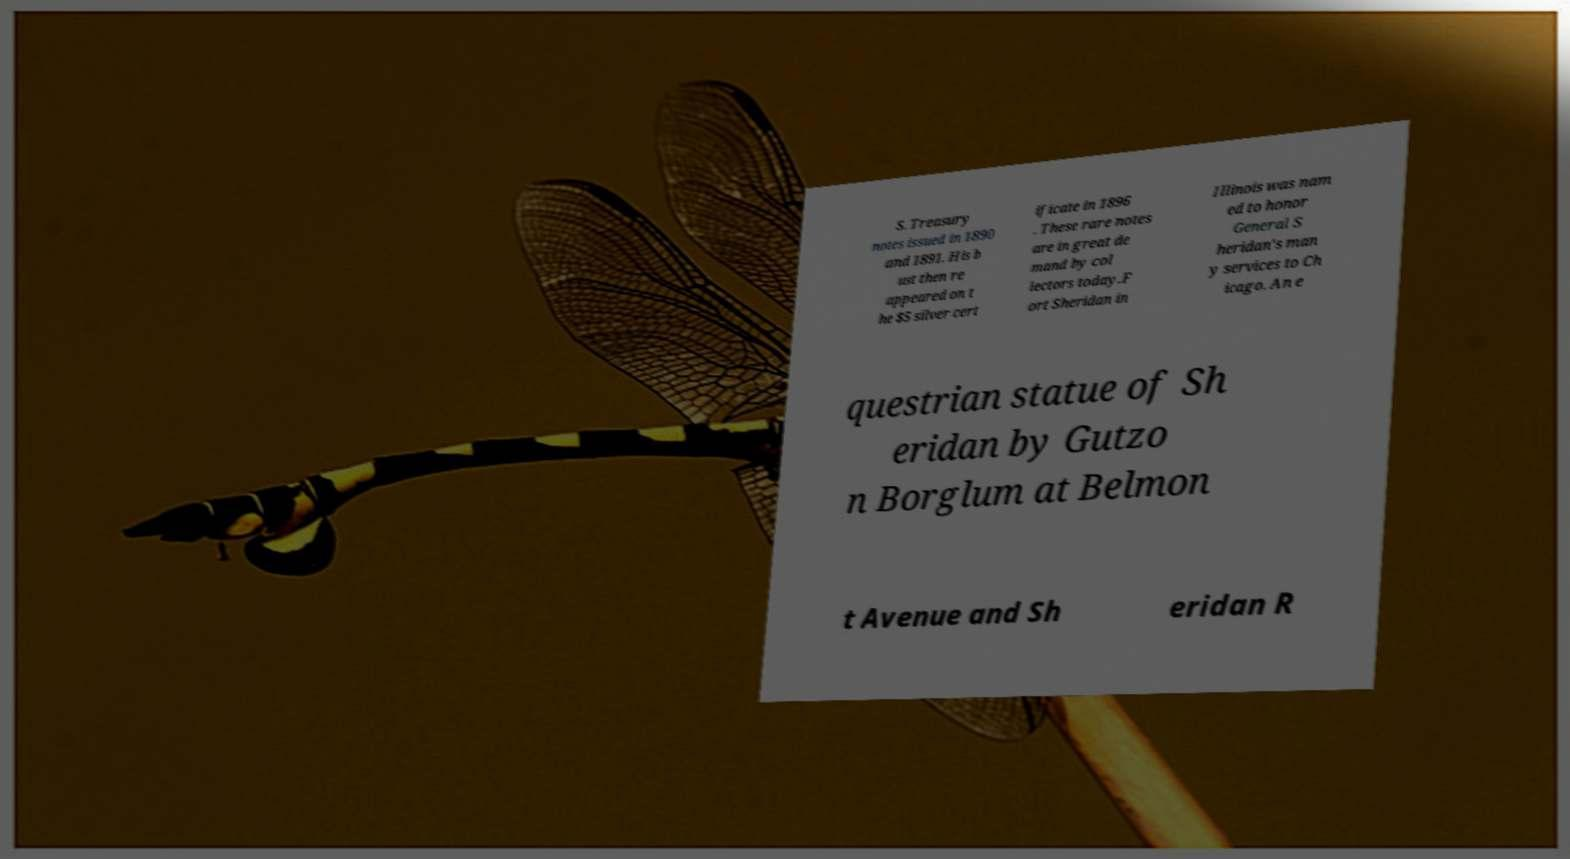There's text embedded in this image that I need extracted. Can you transcribe it verbatim? S. Treasury notes issued in 1890 and 1891. His b ust then re appeared on t he $5 silver cert ificate in 1896 . These rare notes are in great de mand by col lectors today.F ort Sheridan in Illinois was nam ed to honor General S heridan's man y services to Ch icago. An e questrian statue of Sh eridan by Gutzo n Borglum at Belmon t Avenue and Sh eridan R 